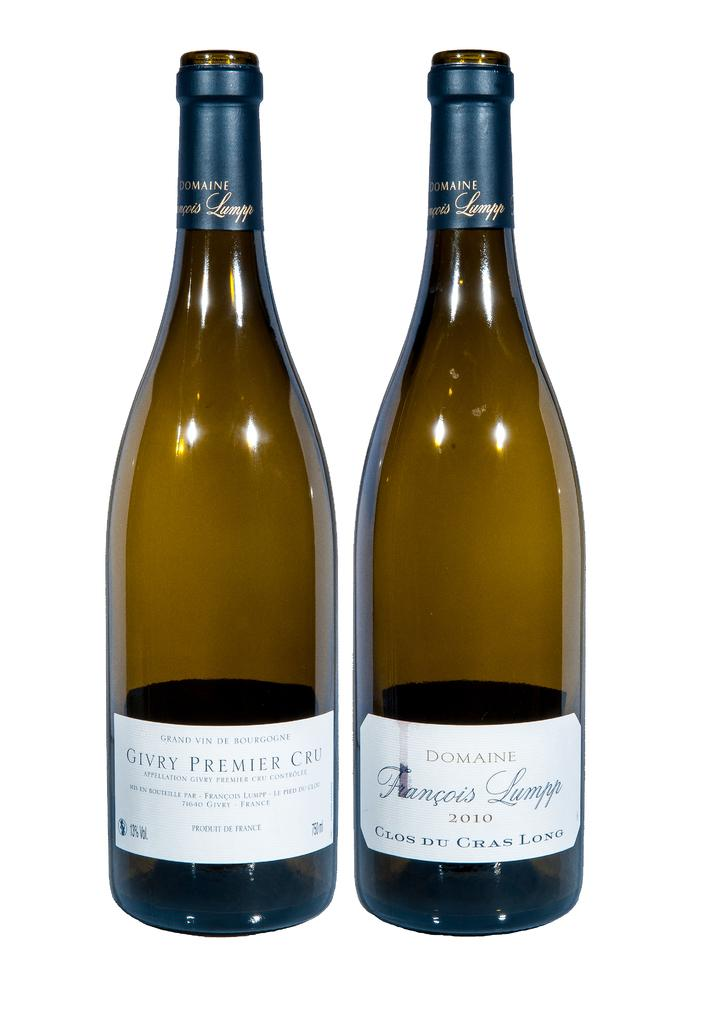<image>
Write a terse but informative summary of the picture. A bottle of wine from 2010 sits next to another bottle. 